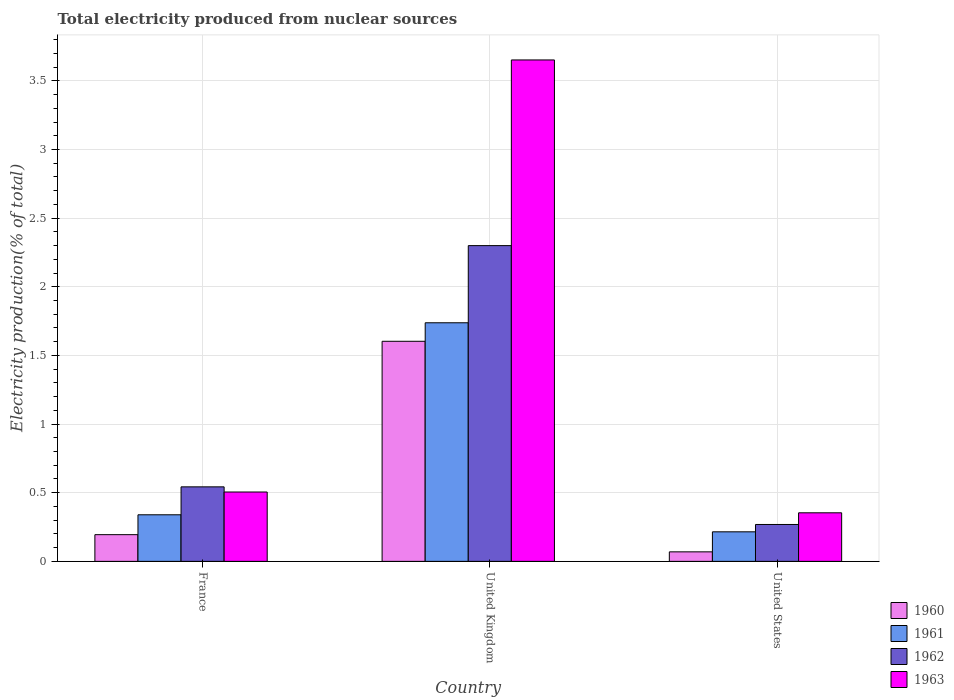Are the number of bars on each tick of the X-axis equal?
Give a very brief answer. Yes. How many bars are there on the 3rd tick from the right?
Your answer should be very brief. 4. What is the label of the 1st group of bars from the left?
Keep it short and to the point. France. In how many cases, is the number of bars for a given country not equal to the number of legend labels?
Your response must be concise. 0. What is the total electricity produced in 1962 in United States?
Provide a short and direct response. 0.27. Across all countries, what is the maximum total electricity produced in 1963?
Give a very brief answer. 3.65. Across all countries, what is the minimum total electricity produced in 1962?
Offer a very short reply. 0.27. In which country was the total electricity produced in 1962 minimum?
Make the answer very short. United States. What is the total total electricity produced in 1962 in the graph?
Make the answer very short. 3.11. What is the difference between the total electricity produced in 1963 in France and that in United States?
Provide a short and direct response. 0.15. What is the difference between the total electricity produced in 1961 in United States and the total electricity produced in 1960 in France?
Make the answer very short. 0.02. What is the average total electricity produced in 1961 per country?
Your answer should be compact. 0.76. What is the difference between the total electricity produced of/in 1961 and total electricity produced of/in 1960 in United Kingdom?
Your answer should be very brief. 0.13. In how many countries, is the total electricity produced in 1961 greater than 3.4 %?
Your answer should be compact. 0. What is the ratio of the total electricity produced in 1963 in France to that in United States?
Keep it short and to the point. 1.43. What is the difference between the highest and the second highest total electricity produced in 1961?
Provide a short and direct response. -1.4. What is the difference between the highest and the lowest total electricity produced in 1962?
Give a very brief answer. 2.03. Is it the case that in every country, the sum of the total electricity produced in 1962 and total electricity produced in 1961 is greater than the sum of total electricity produced in 1963 and total electricity produced in 1960?
Your answer should be compact. No. What does the 3rd bar from the left in United Kingdom represents?
Offer a terse response. 1962. How many countries are there in the graph?
Provide a short and direct response. 3. What is the difference between two consecutive major ticks on the Y-axis?
Your answer should be compact. 0.5. Are the values on the major ticks of Y-axis written in scientific E-notation?
Keep it short and to the point. No. Where does the legend appear in the graph?
Provide a short and direct response. Bottom right. How many legend labels are there?
Ensure brevity in your answer.  4. How are the legend labels stacked?
Offer a terse response. Vertical. What is the title of the graph?
Offer a very short reply. Total electricity produced from nuclear sources. What is the Electricity production(% of total) in 1960 in France?
Offer a very short reply. 0.19. What is the Electricity production(% of total) of 1961 in France?
Your response must be concise. 0.34. What is the Electricity production(% of total) in 1962 in France?
Offer a very short reply. 0.54. What is the Electricity production(% of total) of 1963 in France?
Offer a very short reply. 0.51. What is the Electricity production(% of total) of 1960 in United Kingdom?
Offer a very short reply. 1.6. What is the Electricity production(% of total) in 1961 in United Kingdom?
Your answer should be very brief. 1.74. What is the Electricity production(% of total) in 1962 in United Kingdom?
Provide a succinct answer. 2.3. What is the Electricity production(% of total) of 1963 in United Kingdom?
Offer a very short reply. 3.65. What is the Electricity production(% of total) in 1960 in United States?
Your answer should be very brief. 0.07. What is the Electricity production(% of total) of 1961 in United States?
Keep it short and to the point. 0.22. What is the Electricity production(% of total) in 1962 in United States?
Provide a short and direct response. 0.27. What is the Electricity production(% of total) of 1963 in United States?
Ensure brevity in your answer.  0.35. Across all countries, what is the maximum Electricity production(% of total) in 1960?
Provide a short and direct response. 1.6. Across all countries, what is the maximum Electricity production(% of total) in 1961?
Ensure brevity in your answer.  1.74. Across all countries, what is the maximum Electricity production(% of total) of 1962?
Your response must be concise. 2.3. Across all countries, what is the maximum Electricity production(% of total) of 1963?
Your response must be concise. 3.65. Across all countries, what is the minimum Electricity production(% of total) in 1960?
Your response must be concise. 0.07. Across all countries, what is the minimum Electricity production(% of total) in 1961?
Make the answer very short. 0.22. Across all countries, what is the minimum Electricity production(% of total) of 1962?
Your response must be concise. 0.27. Across all countries, what is the minimum Electricity production(% of total) in 1963?
Give a very brief answer. 0.35. What is the total Electricity production(% of total) in 1960 in the graph?
Provide a short and direct response. 1.87. What is the total Electricity production(% of total) in 1961 in the graph?
Your answer should be very brief. 2.29. What is the total Electricity production(% of total) of 1962 in the graph?
Offer a very short reply. 3.11. What is the total Electricity production(% of total) in 1963 in the graph?
Offer a very short reply. 4.51. What is the difference between the Electricity production(% of total) in 1960 in France and that in United Kingdom?
Make the answer very short. -1.41. What is the difference between the Electricity production(% of total) of 1961 in France and that in United Kingdom?
Your answer should be compact. -1.4. What is the difference between the Electricity production(% of total) of 1962 in France and that in United Kingdom?
Provide a short and direct response. -1.76. What is the difference between the Electricity production(% of total) of 1963 in France and that in United Kingdom?
Give a very brief answer. -3.15. What is the difference between the Electricity production(% of total) in 1960 in France and that in United States?
Offer a very short reply. 0.13. What is the difference between the Electricity production(% of total) in 1961 in France and that in United States?
Your answer should be very brief. 0.12. What is the difference between the Electricity production(% of total) of 1962 in France and that in United States?
Offer a very short reply. 0.27. What is the difference between the Electricity production(% of total) in 1963 in France and that in United States?
Give a very brief answer. 0.15. What is the difference between the Electricity production(% of total) of 1960 in United Kingdom and that in United States?
Provide a short and direct response. 1.53. What is the difference between the Electricity production(% of total) of 1961 in United Kingdom and that in United States?
Keep it short and to the point. 1.52. What is the difference between the Electricity production(% of total) of 1962 in United Kingdom and that in United States?
Your response must be concise. 2.03. What is the difference between the Electricity production(% of total) of 1963 in United Kingdom and that in United States?
Your answer should be compact. 3.3. What is the difference between the Electricity production(% of total) in 1960 in France and the Electricity production(% of total) in 1961 in United Kingdom?
Offer a very short reply. -1.54. What is the difference between the Electricity production(% of total) of 1960 in France and the Electricity production(% of total) of 1962 in United Kingdom?
Offer a terse response. -2.11. What is the difference between the Electricity production(% of total) of 1960 in France and the Electricity production(% of total) of 1963 in United Kingdom?
Your answer should be compact. -3.46. What is the difference between the Electricity production(% of total) in 1961 in France and the Electricity production(% of total) in 1962 in United Kingdom?
Provide a short and direct response. -1.96. What is the difference between the Electricity production(% of total) in 1961 in France and the Electricity production(% of total) in 1963 in United Kingdom?
Offer a terse response. -3.31. What is the difference between the Electricity production(% of total) of 1962 in France and the Electricity production(% of total) of 1963 in United Kingdom?
Your answer should be very brief. -3.11. What is the difference between the Electricity production(% of total) in 1960 in France and the Electricity production(% of total) in 1961 in United States?
Make the answer very short. -0.02. What is the difference between the Electricity production(% of total) of 1960 in France and the Electricity production(% of total) of 1962 in United States?
Give a very brief answer. -0.07. What is the difference between the Electricity production(% of total) of 1960 in France and the Electricity production(% of total) of 1963 in United States?
Provide a succinct answer. -0.16. What is the difference between the Electricity production(% of total) of 1961 in France and the Electricity production(% of total) of 1962 in United States?
Offer a very short reply. 0.07. What is the difference between the Electricity production(% of total) in 1961 in France and the Electricity production(% of total) in 1963 in United States?
Offer a terse response. -0.01. What is the difference between the Electricity production(% of total) in 1962 in France and the Electricity production(% of total) in 1963 in United States?
Offer a very short reply. 0.19. What is the difference between the Electricity production(% of total) in 1960 in United Kingdom and the Electricity production(% of total) in 1961 in United States?
Ensure brevity in your answer.  1.39. What is the difference between the Electricity production(% of total) in 1960 in United Kingdom and the Electricity production(% of total) in 1962 in United States?
Keep it short and to the point. 1.33. What is the difference between the Electricity production(% of total) of 1960 in United Kingdom and the Electricity production(% of total) of 1963 in United States?
Offer a very short reply. 1.25. What is the difference between the Electricity production(% of total) in 1961 in United Kingdom and the Electricity production(% of total) in 1962 in United States?
Offer a very short reply. 1.47. What is the difference between the Electricity production(% of total) in 1961 in United Kingdom and the Electricity production(% of total) in 1963 in United States?
Your answer should be very brief. 1.38. What is the difference between the Electricity production(% of total) of 1962 in United Kingdom and the Electricity production(% of total) of 1963 in United States?
Provide a succinct answer. 1.95. What is the average Electricity production(% of total) in 1960 per country?
Provide a short and direct response. 0.62. What is the average Electricity production(% of total) in 1961 per country?
Offer a very short reply. 0.76. What is the average Electricity production(% of total) of 1963 per country?
Provide a succinct answer. 1.5. What is the difference between the Electricity production(% of total) in 1960 and Electricity production(% of total) in 1961 in France?
Make the answer very short. -0.14. What is the difference between the Electricity production(% of total) in 1960 and Electricity production(% of total) in 1962 in France?
Your response must be concise. -0.35. What is the difference between the Electricity production(% of total) of 1960 and Electricity production(% of total) of 1963 in France?
Ensure brevity in your answer.  -0.31. What is the difference between the Electricity production(% of total) in 1961 and Electricity production(% of total) in 1962 in France?
Ensure brevity in your answer.  -0.2. What is the difference between the Electricity production(% of total) in 1961 and Electricity production(% of total) in 1963 in France?
Ensure brevity in your answer.  -0.17. What is the difference between the Electricity production(% of total) in 1962 and Electricity production(% of total) in 1963 in France?
Provide a short and direct response. 0.04. What is the difference between the Electricity production(% of total) in 1960 and Electricity production(% of total) in 1961 in United Kingdom?
Your response must be concise. -0.13. What is the difference between the Electricity production(% of total) in 1960 and Electricity production(% of total) in 1962 in United Kingdom?
Offer a terse response. -0.7. What is the difference between the Electricity production(% of total) of 1960 and Electricity production(% of total) of 1963 in United Kingdom?
Your response must be concise. -2.05. What is the difference between the Electricity production(% of total) in 1961 and Electricity production(% of total) in 1962 in United Kingdom?
Give a very brief answer. -0.56. What is the difference between the Electricity production(% of total) of 1961 and Electricity production(% of total) of 1963 in United Kingdom?
Give a very brief answer. -1.91. What is the difference between the Electricity production(% of total) in 1962 and Electricity production(% of total) in 1963 in United Kingdom?
Make the answer very short. -1.35. What is the difference between the Electricity production(% of total) in 1960 and Electricity production(% of total) in 1961 in United States?
Provide a short and direct response. -0.15. What is the difference between the Electricity production(% of total) of 1960 and Electricity production(% of total) of 1962 in United States?
Provide a succinct answer. -0.2. What is the difference between the Electricity production(% of total) in 1960 and Electricity production(% of total) in 1963 in United States?
Your answer should be very brief. -0.28. What is the difference between the Electricity production(% of total) of 1961 and Electricity production(% of total) of 1962 in United States?
Offer a very short reply. -0.05. What is the difference between the Electricity production(% of total) of 1961 and Electricity production(% of total) of 1963 in United States?
Offer a terse response. -0.14. What is the difference between the Electricity production(% of total) of 1962 and Electricity production(% of total) of 1963 in United States?
Offer a very short reply. -0.09. What is the ratio of the Electricity production(% of total) in 1960 in France to that in United Kingdom?
Your answer should be compact. 0.12. What is the ratio of the Electricity production(% of total) in 1961 in France to that in United Kingdom?
Provide a succinct answer. 0.2. What is the ratio of the Electricity production(% of total) of 1962 in France to that in United Kingdom?
Keep it short and to the point. 0.24. What is the ratio of the Electricity production(% of total) in 1963 in France to that in United Kingdom?
Make the answer very short. 0.14. What is the ratio of the Electricity production(% of total) of 1960 in France to that in United States?
Offer a terse response. 2.81. What is the ratio of the Electricity production(% of total) in 1961 in France to that in United States?
Keep it short and to the point. 1.58. What is the ratio of the Electricity production(% of total) of 1962 in France to that in United States?
Make the answer very short. 2.02. What is the ratio of the Electricity production(% of total) of 1963 in France to that in United States?
Provide a short and direct response. 1.43. What is the ratio of the Electricity production(% of total) of 1960 in United Kingdom to that in United States?
Ensure brevity in your answer.  23.14. What is the ratio of the Electricity production(% of total) of 1961 in United Kingdom to that in United States?
Your answer should be very brief. 8.08. What is the ratio of the Electricity production(% of total) in 1962 in United Kingdom to that in United States?
Make the answer very short. 8.56. What is the ratio of the Electricity production(% of total) in 1963 in United Kingdom to that in United States?
Provide a short and direct response. 10.32. What is the difference between the highest and the second highest Electricity production(% of total) of 1960?
Ensure brevity in your answer.  1.41. What is the difference between the highest and the second highest Electricity production(% of total) of 1961?
Your answer should be very brief. 1.4. What is the difference between the highest and the second highest Electricity production(% of total) of 1962?
Provide a short and direct response. 1.76. What is the difference between the highest and the second highest Electricity production(% of total) of 1963?
Provide a short and direct response. 3.15. What is the difference between the highest and the lowest Electricity production(% of total) of 1960?
Your answer should be very brief. 1.53. What is the difference between the highest and the lowest Electricity production(% of total) in 1961?
Keep it short and to the point. 1.52. What is the difference between the highest and the lowest Electricity production(% of total) of 1962?
Give a very brief answer. 2.03. What is the difference between the highest and the lowest Electricity production(% of total) in 1963?
Ensure brevity in your answer.  3.3. 